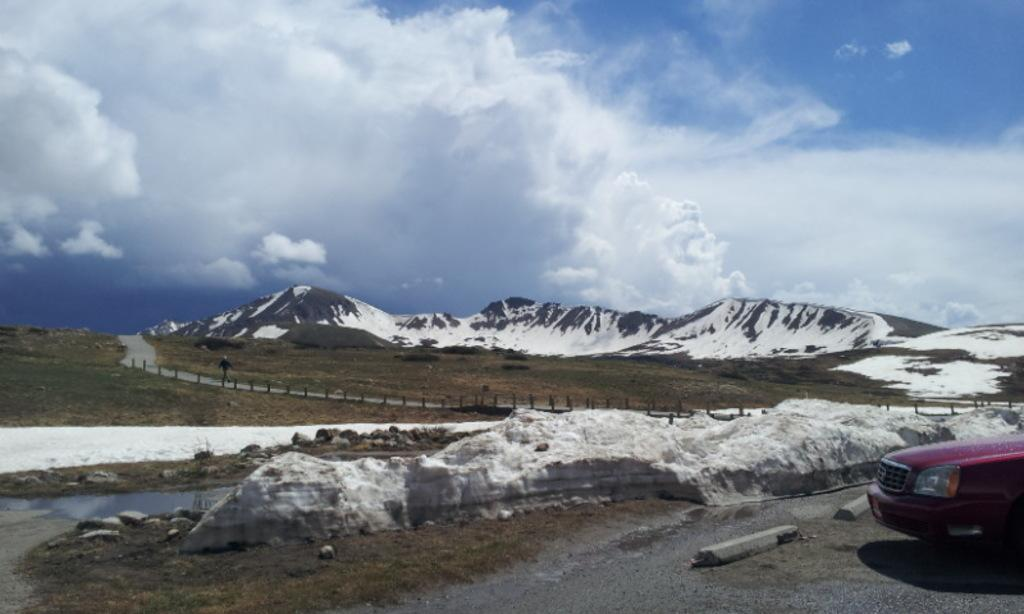What is the main subject of the image? The main subject of the image is a vehicle. Where is the vehicle located? The vehicle is on a road. What can be seen in the background of the image? Mountains and the sky are visible in the background of the image. What type of hot beverage is being served by the robin in the image? There is no robin or hot beverage present in the image. What type of selection process is being conducted in the image? There is no selection process visible in the image. 